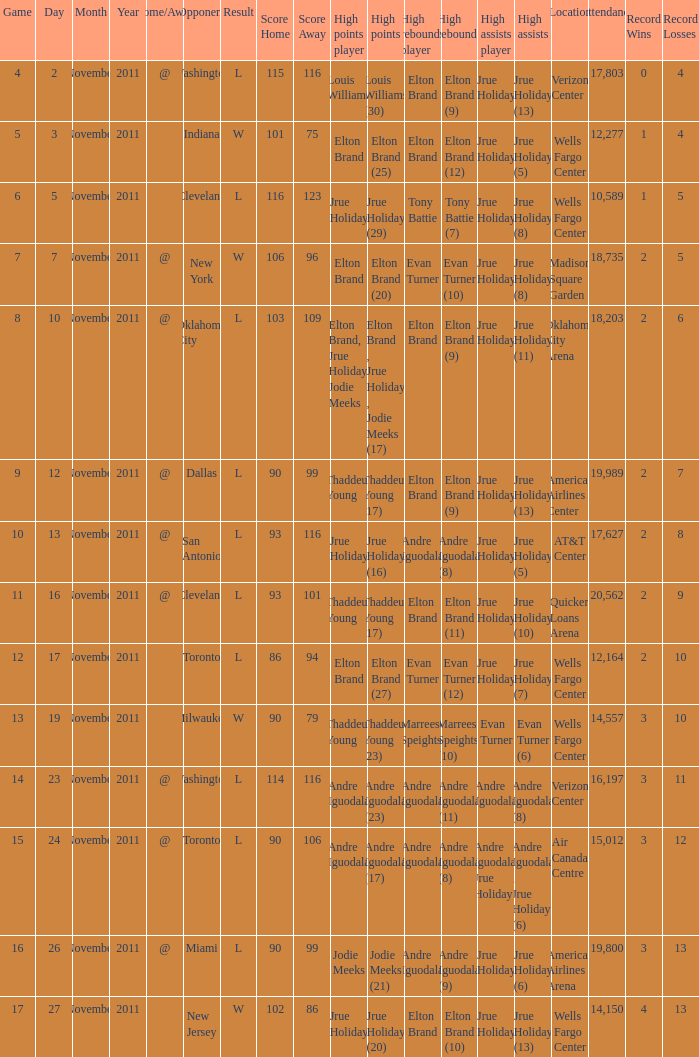Parse the table in full. {'header': ['Game', 'Day', 'Month', 'Year', 'Home/Away', 'Opponent', 'Result', 'Score Home', 'Score Away', 'High points player', 'High points', 'High rebounds player', 'High rebounds', 'High assists player', 'High assists', 'Location', 'Attendance', 'Record Wins', 'Record Losses'], 'rows': [['4', '2', 'November', '2011', '@', 'Washington', 'L', '115', '116', 'Louis Williams', 'Louis Williams (30)', 'Elton Brand', 'Elton Brand (9)', 'Jrue Holiday', 'Jrue Holiday (13)', 'Verizon Center', '17,803', '0', '4'], ['5', '3', 'November', '2011', '', 'Indiana', 'W', '101', '75', 'Elton Brand', 'Elton Brand (25)', 'Elton Brand', 'Elton Brand (12)', 'Jrue Holiday', 'Jrue Holiday (5)', 'Wells Fargo Center', '12,277', '1', '4'], ['6', '5', 'November', '2011', '', 'Cleveland', 'L', '116', '123', 'Jrue Holiday', 'Jrue Holiday (29)', 'Tony Battie', 'Tony Battie (7)', 'Jrue Holiday', 'Jrue Holiday (8)', 'Wells Fargo Center', '10,589', '1', '5'], ['7', '7', 'November', '2011', '@', 'New York', 'W', '106', '96', 'Elton Brand', 'Elton Brand (20)', 'Evan Turner', 'Evan Turner (10)', 'Jrue Holiday', 'Jrue Holiday (8)', 'Madison Square Garden', '18,735', '2', '5'], ['8', '10', 'November', '2011', '@', 'Oklahoma City', 'L', '103', '109', 'Elton Brand, Jrue Holiday, Jodie Meeks', 'Elton Brand , Jrue Holiday , Jodie Meeks (17)', 'Elton Brand', 'Elton Brand (9)', 'Jrue Holiday', 'Jrue Holiday (11)', 'Oklahoma City Arena', '18,203', '2', '6'], ['9', '12', 'November', '2011', '@', 'Dallas', 'L', '90', '99', 'Thaddeus Young', 'Thaddeus Young (17)', 'Elton Brand', 'Elton Brand (9)', 'Jrue Holiday', 'Jrue Holiday (13)', 'American Airlines Center', '19,989', '2', '7'], ['10', '13', 'November', '2011', '@', 'San Antonio', 'L', '93', '116', 'Jrue Holiday', 'Jrue Holiday (16)', 'Andre Iguodala', 'Andre Iguodala (8)', 'Jrue Holiday', 'Jrue Holiday (5)', 'AT&T Center', '17,627', '2', '8'], ['11', '16', 'November', '2011', '@', 'Cleveland', 'L', '93', '101', 'Thaddeus Young', 'Thaddeus Young (17)', 'Elton Brand', 'Elton Brand (11)', 'Jrue Holiday', 'Jrue Holiday (10)', 'Quicken Loans Arena', '20,562', '2', '9'], ['12', '17', 'November', '2011', '', 'Toronto', 'L', '86', '94', 'Elton Brand', 'Elton Brand (27)', 'Evan Turner', 'Evan Turner (12)', 'Jrue Holiday', 'Jrue Holiday (7)', 'Wells Fargo Center', '12,164', '2', '10'], ['13', '19', 'November', '2011', '', 'Milwaukee', 'W', '90', '79', 'Thaddeus Young', 'Thaddeus Young (23)', 'Marreese Speights', 'Marreese Speights (10)', 'Evan Turner', 'Evan Turner (6)', 'Wells Fargo Center', '14,557', '3', '10'], ['14', '23', 'November', '2011', '@', 'Washington', 'L', '114', '116', 'Andre Iguodala', 'Andre Iguodala (23)', 'Andre Iguodala', 'Andre Iguodala (11)', 'Andre Iguodala', 'Andre Iguodala (8)', 'Verizon Center', '16,197', '3', '11'], ['15', '24', 'November', '2011', '@', 'Toronto', 'L', '90', '106', 'Andre Iguodala', 'Andre Iguodala (17)', 'Andre Iguodala', 'Andre Iguodala (8)', 'Andre Iguodala, Jrue Holiday', 'Andre Iguodala , Jrue Holiday (6)', 'Air Canada Centre', '15,012', '3', '12'], ['16', '26', 'November', '2011', '@', 'Miami', 'L', '90', '99', 'Jodie Meeks', 'Jodie Meeks (21)', 'Andre Iguodala', 'Andre Iguodala (9)', 'Jrue Holiday', 'Jrue Holiday (6)', 'American Airlines Arena', '19,800', '3', '13'], ['17', '27', 'November', '2011', '', 'New Jersey', 'W', '102', '86', 'Jrue Holiday', 'Jrue Holiday (20)', 'Elton Brand', 'Elton Brand (10)', 'Jrue Holiday', 'Jrue Holiday (13)', 'Wells Fargo Center', '14,150', '4', '13']]} What is the score for the game with the record of 3–12? L 90–106 (OT). 